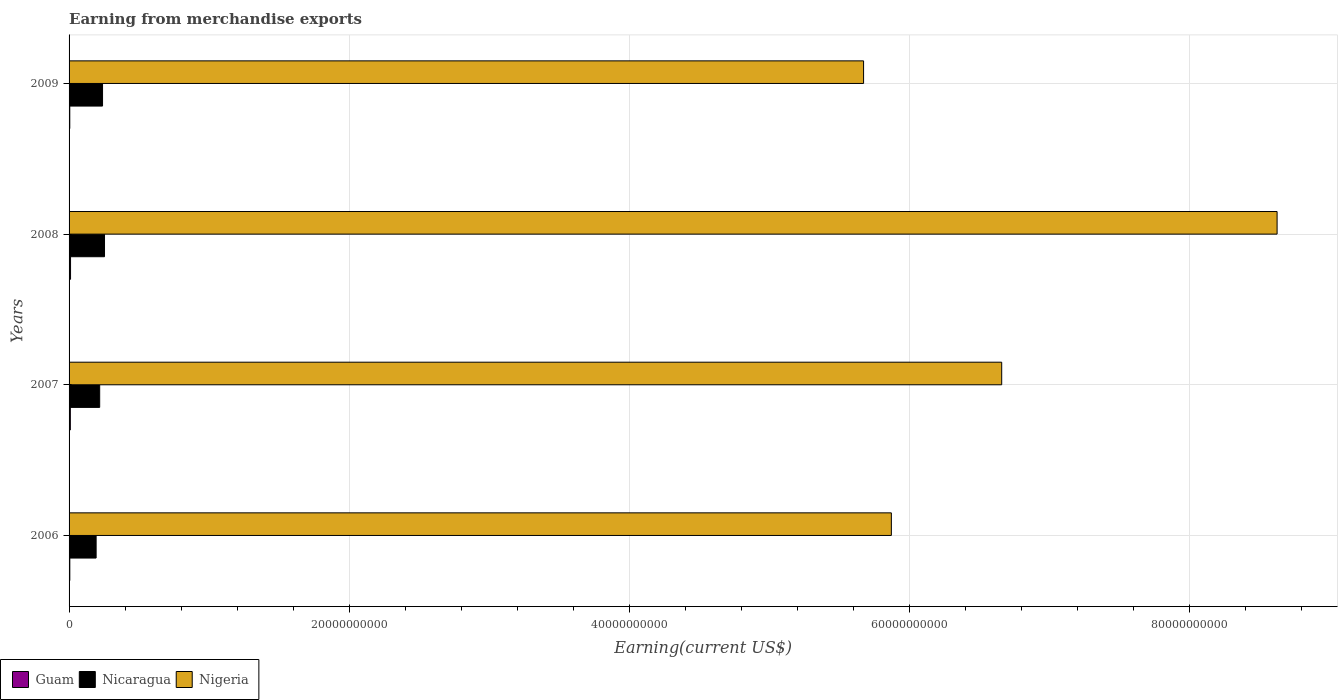How many different coloured bars are there?
Ensure brevity in your answer.  3. How many groups of bars are there?
Provide a short and direct response. 4. Are the number of bars on each tick of the Y-axis equal?
Give a very brief answer. Yes. In how many cases, is the number of bars for a given year not equal to the number of legend labels?
Offer a terse response. 0. What is the amount earned from merchandise exports in Nigeria in 2008?
Provide a short and direct response. 8.63e+1. Across all years, what is the maximum amount earned from merchandise exports in Nicaragua?
Provide a short and direct response. 2.53e+09. Across all years, what is the minimum amount earned from merchandise exports in Guam?
Offer a very short reply. 5.13e+07. What is the total amount earned from merchandise exports in Nicaragua in the graph?
Offer a terse response. 9.04e+09. What is the difference between the amount earned from merchandise exports in Nigeria in 2007 and that in 2008?
Make the answer very short. -1.97e+1. What is the difference between the amount earned from merchandise exports in Guam in 2006 and the amount earned from merchandise exports in Nigeria in 2008?
Provide a short and direct response. -8.62e+1. What is the average amount earned from merchandise exports in Nicaragua per year?
Give a very brief answer. 2.26e+09. In the year 2008, what is the difference between the amount earned from merchandise exports in Nigeria and amount earned from merchandise exports in Guam?
Your response must be concise. 8.62e+1. What is the ratio of the amount earned from merchandise exports in Nicaragua in 2006 to that in 2008?
Ensure brevity in your answer.  0.76. What is the difference between the highest and the second highest amount earned from merchandise exports in Guam?
Your answer should be very brief. 1.35e+07. What is the difference between the highest and the lowest amount earned from merchandise exports in Nigeria?
Your answer should be compact. 2.95e+1. What does the 1st bar from the top in 2006 represents?
Make the answer very short. Nigeria. What does the 1st bar from the bottom in 2009 represents?
Give a very brief answer. Guam. How many bars are there?
Make the answer very short. 12. Are the values on the major ticks of X-axis written in scientific E-notation?
Give a very brief answer. No. Does the graph contain any zero values?
Ensure brevity in your answer.  No. Does the graph contain grids?
Offer a terse response. Yes. Where does the legend appear in the graph?
Provide a short and direct response. Bottom left. How many legend labels are there?
Offer a terse response. 3. What is the title of the graph?
Offer a terse response. Earning from merchandise exports. What is the label or title of the X-axis?
Provide a succinct answer. Earning(current US$). What is the Earning(current US$) of Guam in 2006?
Offer a very short reply. 5.30e+07. What is the Earning(current US$) in Nicaragua in 2006?
Keep it short and to the point. 1.93e+09. What is the Earning(current US$) in Nigeria in 2006?
Your answer should be very brief. 5.87e+1. What is the Earning(current US$) of Guam in 2007?
Keep it short and to the point. 9.14e+07. What is the Earning(current US$) of Nicaragua in 2007?
Make the answer very short. 2.19e+09. What is the Earning(current US$) of Nigeria in 2007?
Give a very brief answer. 6.66e+1. What is the Earning(current US$) in Guam in 2008?
Offer a very short reply. 1.05e+08. What is the Earning(current US$) of Nicaragua in 2008?
Provide a short and direct response. 2.53e+09. What is the Earning(current US$) of Nigeria in 2008?
Your answer should be very brief. 8.63e+1. What is the Earning(current US$) in Guam in 2009?
Offer a terse response. 5.13e+07. What is the Earning(current US$) in Nicaragua in 2009?
Keep it short and to the point. 2.39e+09. What is the Earning(current US$) in Nigeria in 2009?
Keep it short and to the point. 5.67e+1. Across all years, what is the maximum Earning(current US$) of Guam?
Your answer should be compact. 1.05e+08. Across all years, what is the maximum Earning(current US$) in Nicaragua?
Make the answer very short. 2.53e+09. Across all years, what is the maximum Earning(current US$) of Nigeria?
Your answer should be very brief. 8.63e+1. Across all years, what is the minimum Earning(current US$) of Guam?
Provide a short and direct response. 5.13e+07. Across all years, what is the minimum Earning(current US$) of Nicaragua?
Make the answer very short. 1.93e+09. Across all years, what is the minimum Earning(current US$) in Nigeria?
Your answer should be very brief. 5.67e+1. What is the total Earning(current US$) of Guam in the graph?
Your response must be concise. 3.00e+08. What is the total Earning(current US$) of Nicaragua in the graph?
Make the answer very short. 9.04e+09. What is the total Earning(current US$) in Nigeria in the graph?
Ensure brevity in your answer.  2.68e+11. What is the difference between the Earning(current US$) of Guam in 2006 and that in 2007?
Provide a succinct answer. -3.84e+07. What is the difference between the Earning(current US$) of Nicaragua in 2006 and that in 2007?
Your answer should be very brief. -2.54e+08. What is the difference between the Earning(current US$) in Nigeria in 2006 and that in 2007?
Your answer should be compact. -7.88e+09. What is the difference between the Earning(current US$) in Guam in 2006 and that in 2008?
Your response must be concise. -5.19e+07. What is the difference between the Earning(current US$) in Nicaragua in 2006 and that in 2008?
Your answer should be very brief. -5.99e+08. What is the difference between the Earning(current US$) of Nigeria in 2006 and that in 2008?
Offer a very short reply. -2.75e+1. What is the difference between the Earning(current US$) of Guam in 2006 and that in 2009?
Offer a very short reply. 1.68e+06. What is the difference between the Earning(current US$) in Nicaragua in 2006 and that in 2009?
Your response must be concise. -4.58e+08. What is the difference between the Earning(current US$) in Nigeria in 2006 and that in 2009?
Your response must be concise. 1.98e+09. What is the difference between the Earning(current US$) of Guam in 2007 and that in 2008?
Give a very brief answer. -1.35e+07. What is the difference between the Earning(current US$) of Nicaragua in 2007 and that in 2008?
Your answer should be very brief. -3.45e+08. What is the difference between the Earning(current US$) of Nigeria in 2007 and that in 2008?
Your answer should be very brief. -1.97e+1. What is the difference between the Earning(current US$) of Guam in 2007 and that in 2009?
Offer a terse response. 4.01e+07. What is the difference between the Earning(current US$) of Nicaragua in 2007 and that in 2009?
Your response must be concise. -2.04e+08. What is the difference between the Earning(current US$) in Nigeria in 2007 and that in 2009?
Provide a succinct answer. 9.86e+09. What is the difference between the Earning(current US$) of Guam in 2008 and that in 2009?
Offer a very short reply. 5.36e+07. What is the difference between the Earning(current US$) of Nicaragua in 2008 and that in 2009?
Offer a terse response. 1.41e+08. What is the difference between the Earning(current US$) of Nigeria in 2008 and that in 2009?
Your response must be concise. 2.95e+1. What is the difference between the Earning(current US$) of Guam in 2006 and the Earning(current US$) of Nicaragua in 2007?
Provide a short and direct response. -2.13e+09. What is the difference between the Earning(current US$) of Guam in 2006 and the Earning(current US$) of Nigeria in 2007?
Provide a short and direct response. -6.66e+1. What is the difference between the Earning(current US$) in Nicaragua in 2006 and the Earning(current US$) in Nigeria in 2007?
Your answer should be very brief. -6.47e+1. What is the difference between the Earning(current US$) of Guam in 2006 and the Earning(current US$) of Nicaragua in 2008?
Provide a short and direct response. -2.48e+09. What is the difference between the Earning(current US$) in Guam in 2006 and the Earning(current US$) in Nigeria in 2008?
Your answer should be very brief. -8.62e+1. What is the difference between the Earning(current US$) in Nicaragua in 2006 and the Earning(current US$) in Nigeria in 2008?
Offer a very short reply. -8.43e+1. What is the difference between the Earning(current US$) in Guam in 2006 and the Earning(current US$) in Nicaragua in 2009?
Your response must be concise. -2.34e+09. What is the difference between the Earning(current US$) of Guam in 2006 and the Earning(current US$) of Nigeria in 2009?
Ensure brevity in your answer.  -5.67e+1. What is the difference between the Earning(current US$) in Nicaragua in 2006 and the Earning(current US$) in Nigeria in 2009?
Provide a short and direct response. -5.48e+1. What is the difference between the Earning(current US$) in Guam in 2007 and the Earning(current US$) in Nicaragua in 2008?
Provide a short and direct response. -2.44e+09. What is the difference between the Earning(current US$) in Guam in 2007 and the Earning(current US$) in Nigeria in 2008?
Make the answer very short. -8.62e+1. What is the difference between the Earning(current US$) of Nicaragua in 2007 and the Earning(current US$) of Nigeria in 2008?
Provide a succinct answer. -8.41e+1. What is the difference between the Earning(current US$) of Guam in 2007 and the Earning(current US$) of Nicaragua in 2009?
Your response must be concise. -2.30e+09. What is the difference between the Earning(current US$) of Guam in 2007 and the Earning(current US$) of Nigeria in 2009?
Offer a very short reply. -5.67e+1. What is the difference between the Earning(current US$) in Nicaragua in 2007 and the Earning(current US$) in Nigeria in 2009?
Your answer should be compact. -5.46e+1. What is the difference between the Earning(current US$) in Guam in 2008 and the Earning(current US$) in Nicaragua in 2009?
Make the answer very short. -2.29e+09. What is the difference between the Earning(current US$) of Guam in 2008 and the Earning(current US$) of Nigeria in 2009?
Provide a succinct answer. -5.66e+1. What is the difference between the Earning(current US$) of Nicaragua in 2008 and the Earning(current US$) of Nigeria in 2009?
Provide a succinct answer. -5.42e+1. What is the average Earning(current US$) in Guam per year?
Keep it short and to the point. 7.51e+07. What is the average Earning(current US$) of Nicaragua per year?
Offer a very short reply. 2.26e+09. What is the average Earning(current US$) in Nigeria per year?
Provide a short and direct response. 6.71e+1. In the year 2006, what is the difference between the Earning(current US$) in Guam and Earning(current US$) in Nicaragua?
Ensure brevity in your answer.  -1.88e+09. In the year 2006, what is the difference between the Earning(current US$) of Guam and Earning(current US$) of Nigeria?
Offer a very short reply. -5.87e+1. In the year 2006, what is the difference between the Earning(current US$) of Nicaragua and Earning(current US$) of Nigeria?
Your answer should be compact. -5.68e+1. In the year 2007, what is the difference between the Earning(current US$) of Guam and Earning(current US$) of Nicaragua?
Provide a short and direct response. -2.09e+09. In the year 2007, what is the difference between the Earning(current US$) in Guam and Earning(current US$) in Nigeria?
Ensure brevity in your answer.  -6.65e+1. In the year 2007, what is the difference between the Earning(current US$) of Nicaragua and Earning(current US$) of Nigeria?
Give a very brief answer. -6.44e+1. In the year 2008, what is the difference between the Earning(current US$) of Guam and Earning(current US$) of Nicaragua?
Your answer should be very brief. -2.43e+09. In the year 2008, what is the difference between the Earning(current US$) in Guam and Earning(current US$) in Nigeria?
Offer a very short reply. -8.62e+1. In the year 2008, what is the difference between the Earning(current US$) in Nicaragua and Earning(current US$) in Nigeria?
Provide a succinct answer. -8.37e+1. In the year 2009, what is the difference between the Earning(current US$) in Guam and Earning(current US$) in Nicaragua?
Give a very brief answer. -2.34e+09. In the year 2009, what is the difference between the Earning(current US$) of Guam and Earning(current US$) of Nigeria?
Give a very brief answer. -5.67e+1. In the year 2009, what is the difference between the Earning(current US$) in Nicaragua and Earning(current US$) in Nigeria?
Provide a succinct answer. -5.44e+1. What is the ratio of the Earning(current US$) of Guam in 2006 to that in 2007?
Your response must be concise. 0.58. What is the ratio of the Earning(current US$) in Nicaragua in 2006 to that in 2007?
Provide a succinct answer. 0.88. What is the ratio of the Earning(current US$) in Nigeria in 2006 to that in 2007?
Ensure brevity in your answer.  0.88. What is the ratio of the Earning(current US$) in Guam in 2006 to that in 2008?
Provide a short and direct response. 0.51. What is the ratio of the Earning(current US$) in Nicaragua in 2006 to that in 2008?
Make the answer very short. 0.76. What is the ratio of the Earning(current US$) of Nigeria in 2006 to that in 2008?
Ensure brevity in your answer.  0.68. What is the ratio of the Earning(current US$) in Guam in 2006 to that in 2009?
Provide a short and direct response. 1.03. What is the ratio of the Earning(current US$) of Nicaragua in 2006 to that in 2009?
Your answer should be very brief. 0.81. What is the ratio of the Earning(current US$) of Nigeria in 2006 to that in 2009?
Offer a terse response. 1.03. What is the ratio of the Earning(current US$) of Guam in 2007 to that in 2008?
Make the answer very short. 0.87. What is the ratio of the Earning(current US$) in Nicaragua in 2007 to that in 2008?
Your response must be concise. 0.86. What is the ratio of the Earning(current US$) in Nigeria in 2007 to that in 2008?
Give a very brief answer. 0.77. What is the ratio of the Earning(current US$) in Guam in 2007 to that in 2009?
Provide a short and direct response. 1.78. What is the ratio of the Earning(current US$) of Nicaragua in 2007 to that in 2009?
Ensure brevity in your answer.  0.91. What is the ratio of the Earning(current US$) of Nigeria in 2007 to that in 2009?
Keep it short and to the point. 1.17. What is the ratio of the Earning(current US$) of Guam in 2008 to that in 2009?
Offer a very short reply. 2.04. What is the ratio of the Earning(current US$) of Nicaragua in 2008 to that in 2009?
Offer a very short reply. 1.06. What is the ratio of the Earning(current US$) in Nigeria in 2008 to that in 2009?
Give a very brief answer. 1.52. What is the difference between the highest and the second highest Earning(current US$) of Guam?
Your answer should be very brief. 1.35e+07. What is the difference between the highest and the second highest Earning(current US$) in Nicaragua?
Ensure brevity in your answer.  1.41e+08. What is the difference between the highest and the second highest Earning(current US$) of Nigeria?
Offer a very short reply. 1.97e+1. What is the difference between the highest and the lowest Earning(current US$) in Guam?
Offer a terse response. 5.36e+07. What is the difference between the highest and the lowest Earning(current US$) of Nicaragua?
Your answer should be very brief. 5.99e+08. What is the difference between the highest and the lowest Earning(current US$) in Nigeria?
Your answer should be compact. 2.95e+1. 